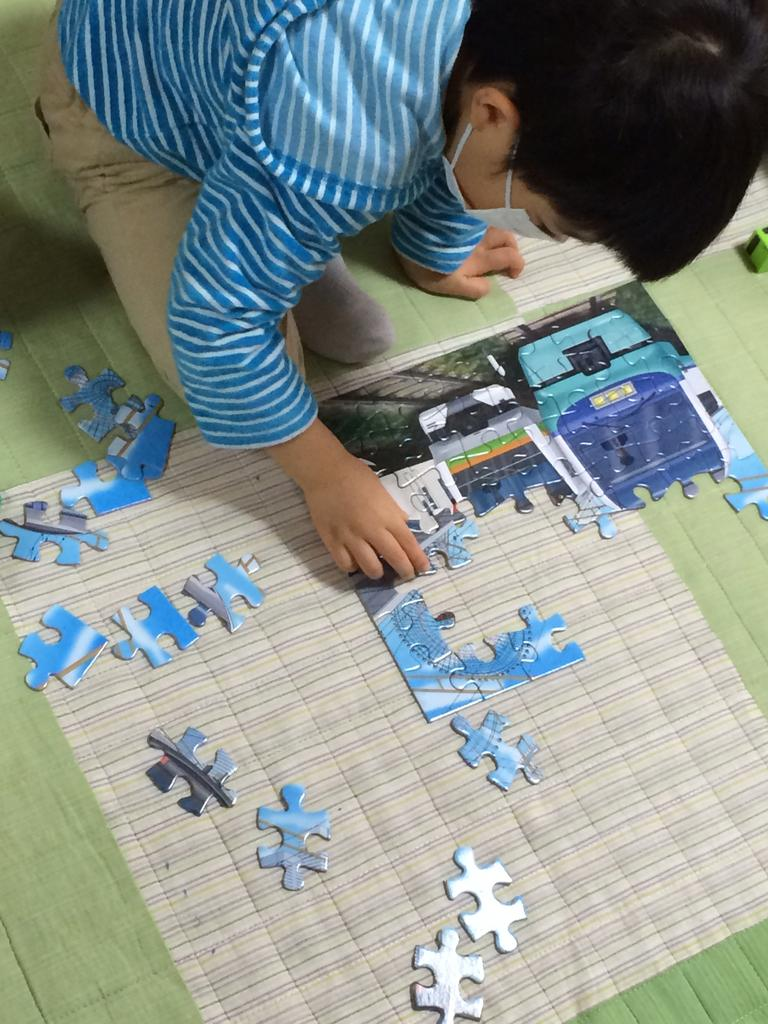What is the main subject of the picture? The main subject of the picture is a kid. What is the kid wearing? The kid is wearing a blue T-shirt and brown pants. What is the kid doing in the picture? The kid is sitting on the floor and playing with a puzzle. Where is the puzzle located in the image? The puzzle is on the floor. What type of parcel is the kid holding in the image? There is no parcel present in the image; the kid is playing with a puzzle. How does the kid's behavior change when they are asked to push the puzzle? The image does not show the kid being asked to push the puzzle, nor does it show any change in behavior. 